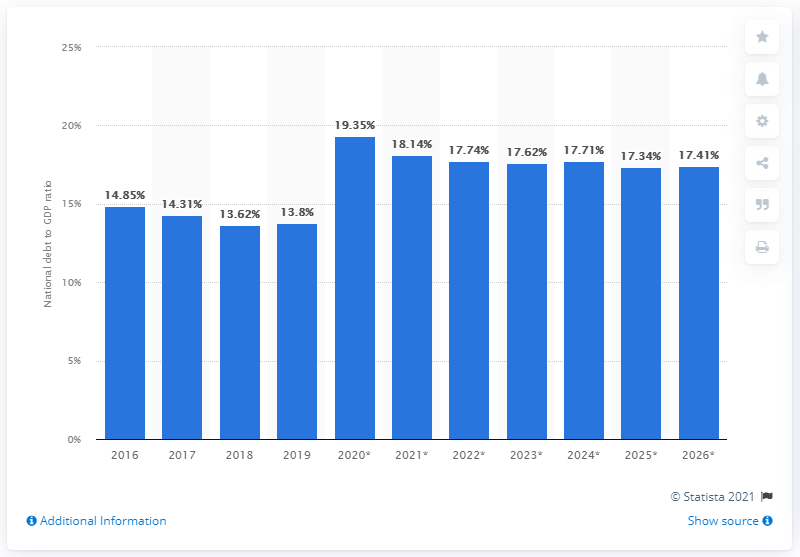Point out several critical features in this image. In 2019, Russia's national debt equaled 13.8% of the country's gross domestic product. 